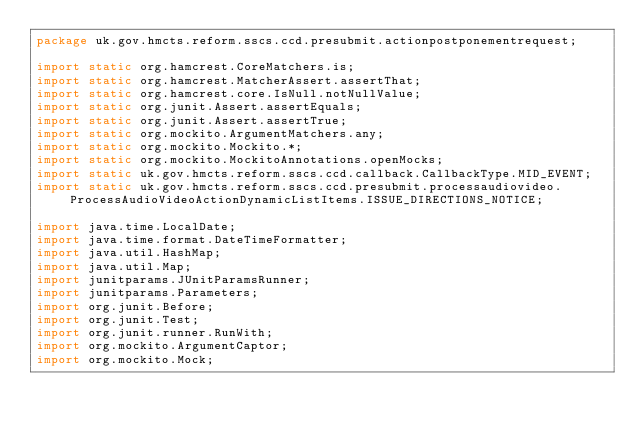<code> <loc_0><loc_0><loc_500><loc_500><_Java_>package uk.gov.hmcts.reform.sscs.ccd.presubmit.actionpostponementrequest;

import static org.hamcrest.CoreMatchers.is;
import static org.hamcrest.MatcherAssert.assertThat;
import static org.hamcrest.core.IsNull.notNullValue;
import static org.junit.Assert.assertEquals;
import static org.junit.Assert.assertTrue;
import static org.mockito.ArgumentMatchers.any;
import static org.mockito.Mockito.*;
import static org.mockito.MockitoAnnotations.openMocks;
import static uk.gov.hmcts.reform.sscs.ccd.callback.CallbackType.MID_EVENT;
import static uk.gov.hmcts.reform.sscs.ccd.presubmit.processaudiovideo.ProcessAudioVideoActionDynamicListItems.ISSUE_DIRECTIONS_NOTICE;

import java.time.LocalDate;
import java.time.format.DateTimeFormatter;
import java.util.HashMap;
import java.util.Map;
import junitparams.JUnitParamsRunner;
import junitparams.Parameters;
import org.junit.Before;
import org.junit.Test;
import org.junit.runner.RunWith;
import org.mockito.ArgumentCaptor;
import org.mockito.Mock;</code> 